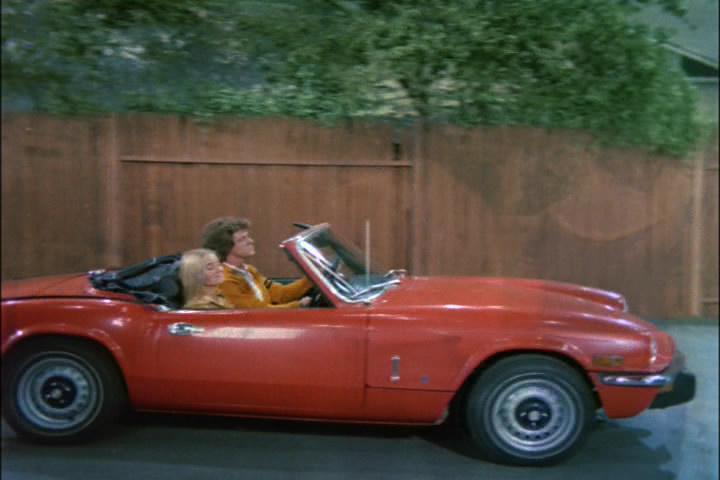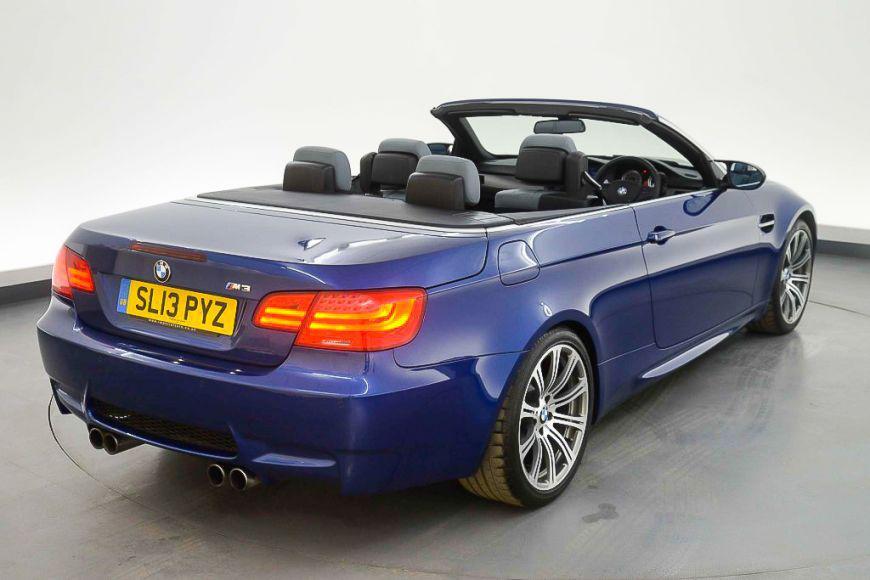The first image is the image on the left, the second image is the image on the right. For the images displayed, is the sentence "Both cars are red." factually correct? Answer yes or no. No. 